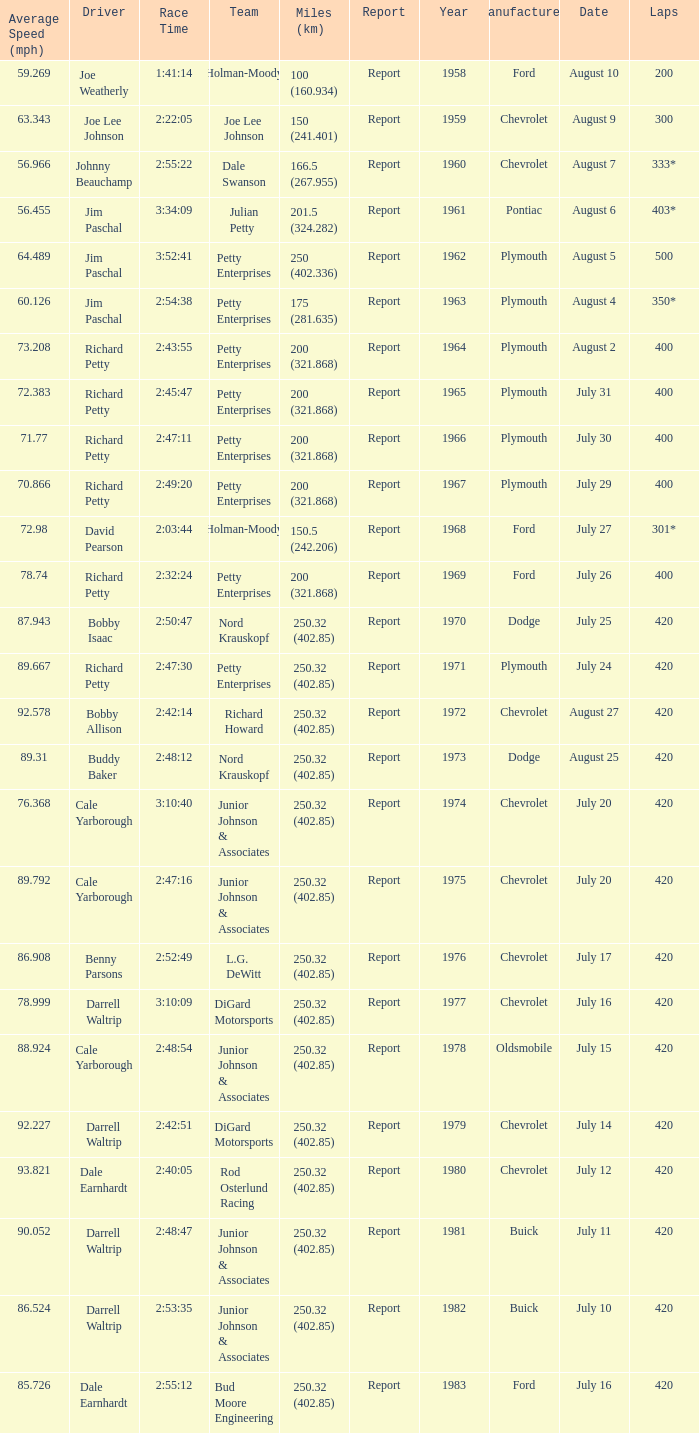How many races did Cale Yarborough win at an average speed of 88.924 mph? 1.0. 